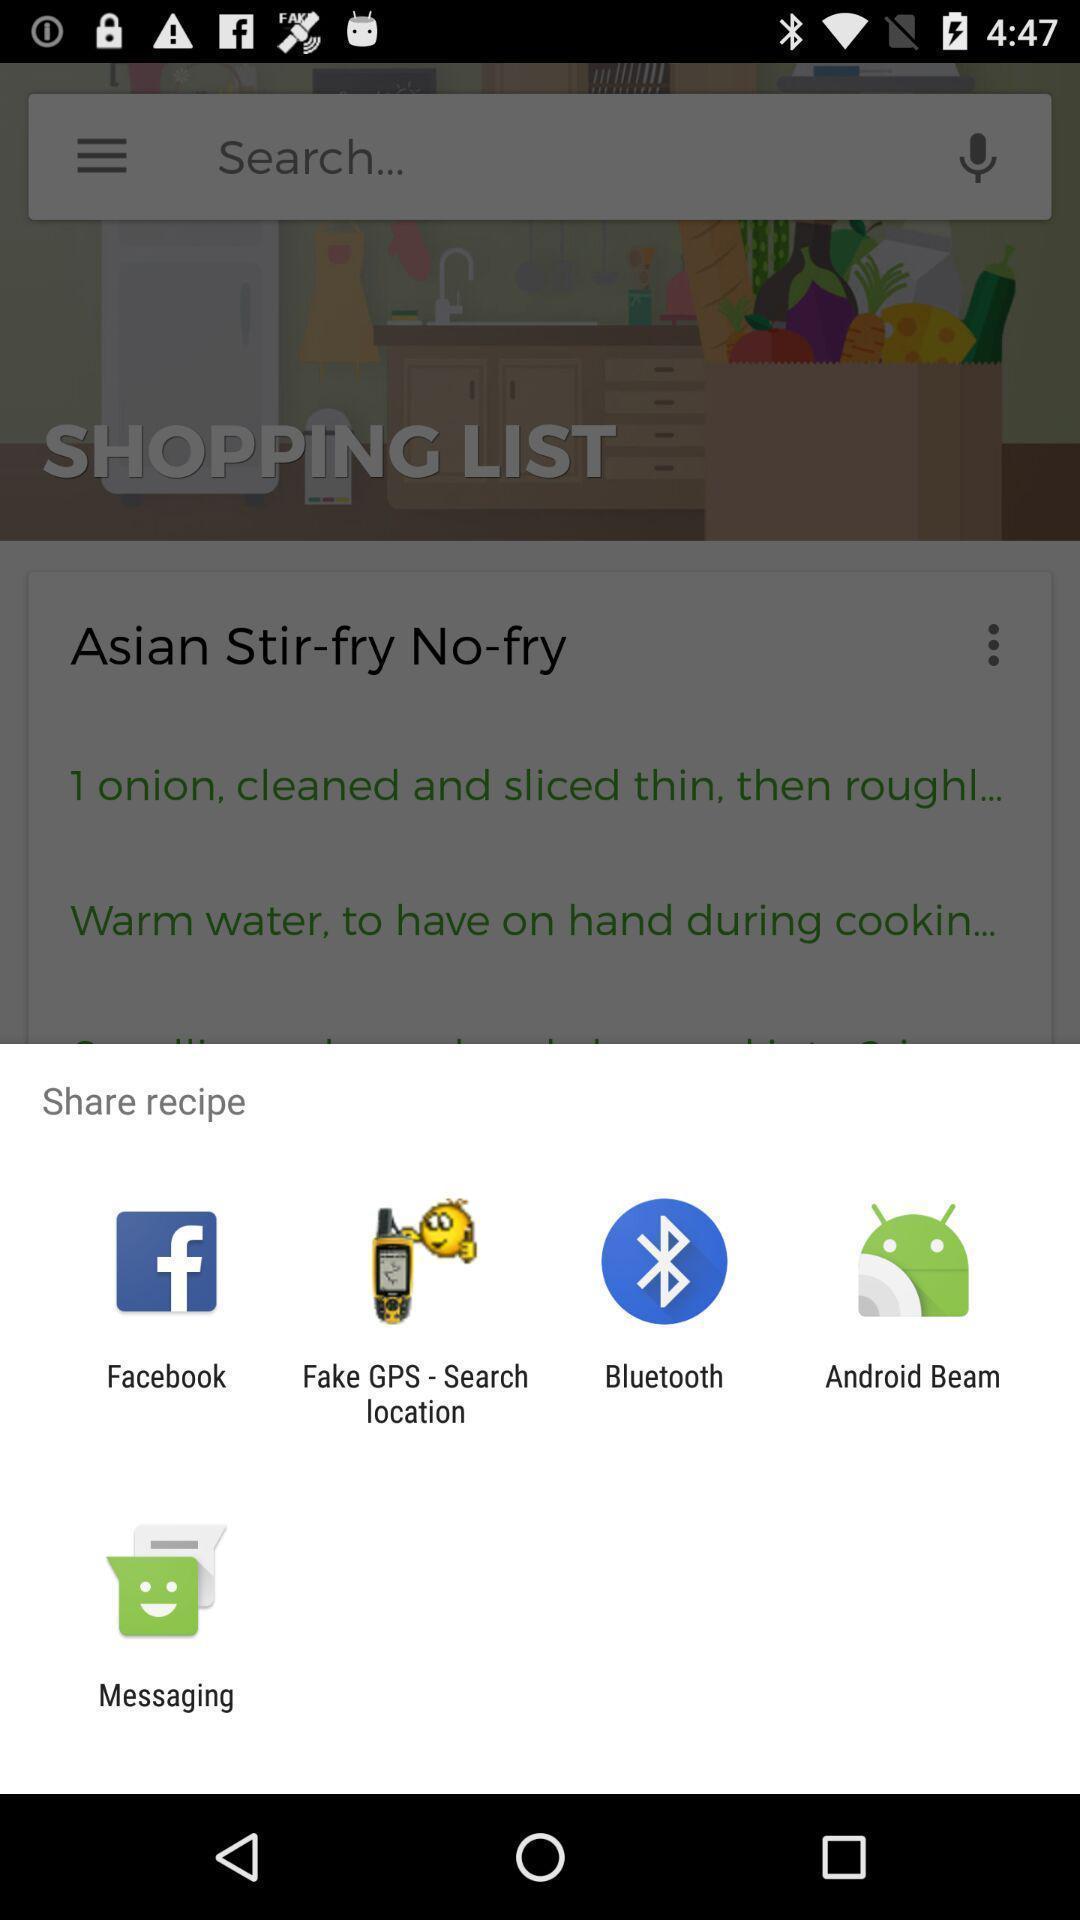Summarize the main components in this picture. Pop-up showing various options to share the recipe. 